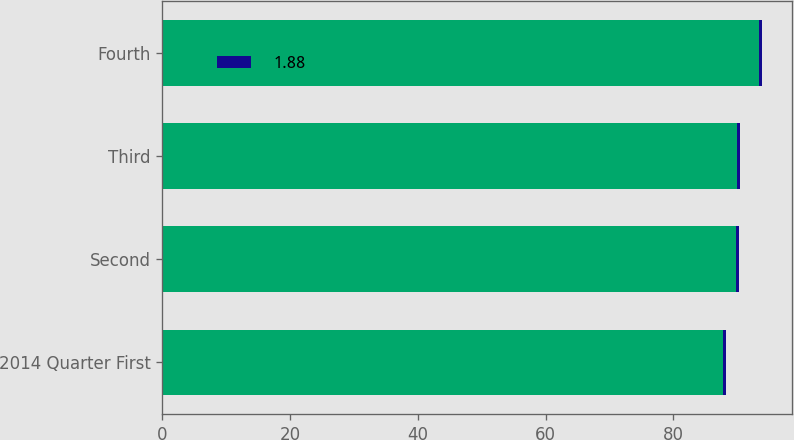Convert chart to OTSL. <chart><loc_0><loc_0><loc_500><loc_500><stacked_bar_chart><ecel><fcel>2014 Quarter First<fcel>Second<fcel>Third<fcel>Fourth<nl><fcel>nan<fcel>87.8<fcel>89.85<fcel>90<fcel>93.45<nl><fcel>1.88<fcel>0.44<fcel>0.48<fcel>0.48<fcel>0.48<nl></chart> 